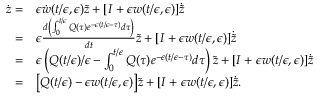Convert formula to latex. <formula><loc_0><loc_0><loc_500><loc_500>\begin{array} { r l } { \dot { z } = } & { \epsilon \dot { w } ( t / \epsilon , \epsilon ) { \tilde { z } } + [ I + \epsilon w ( t / \epsilon , \epsilon ) ] { \dot { \tilde { z } } } } \\ { = } & { \epsilon \frac { d \left ( \int _ { 0 } ^ { t / \epsilon } Q ( \tau ) e ^ { - \epsilon ( t / \epsilon - \tau ) } d \tau \right ) } { d t } \tilde { z } + [ I + \epsilon w ( t / \epsilon , \epsilon ) ] \dot { \tilde { z } } } \\ { = } & { \epsilon \left ( Q ( t / \epsilon ) / \epsilon - \int _ { 0 } ^ { t / \epsilon } Q ( \tau ) e ^ { - \epsilon ( t / \epsilon - \tau ) } d \tau \right ) \tilde { z } + [ I + \epsilon w ( t / \epsilon , \epsilon ) ] \dot { \tilde { z } } } \\ { = } & { \left [ Q ( t / \epsilon ) - \epsilon w ( t / \epsilon , \epsilon ) \right ] { \tilde { z } } + [ I + \epsilon w ( t / \epsilon , \epsilon ) ] { \dot { \tilde { z } } } . } \end{array}</formula> 